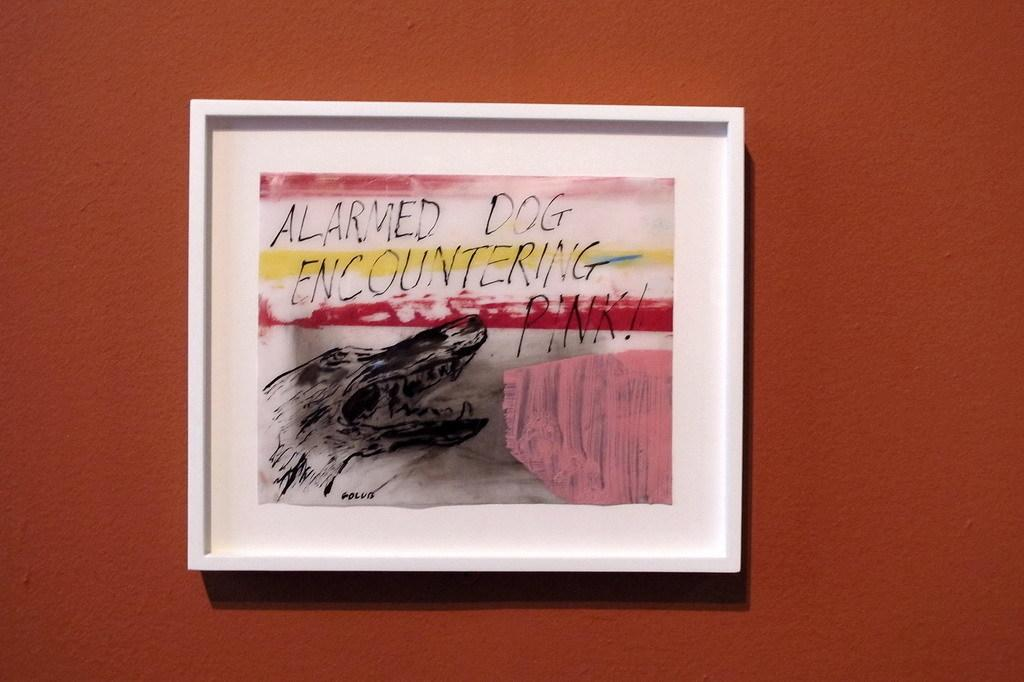What is on the wall in the image? There is a painting on the wall in the image. What can be seen on the painting? There is text on the painting. What color is the wall in the image? The wall is brown in color. What is the taste of the passenger in the image? There is no passenger present in the image, and therefore no taste can be attributed to anyone. 